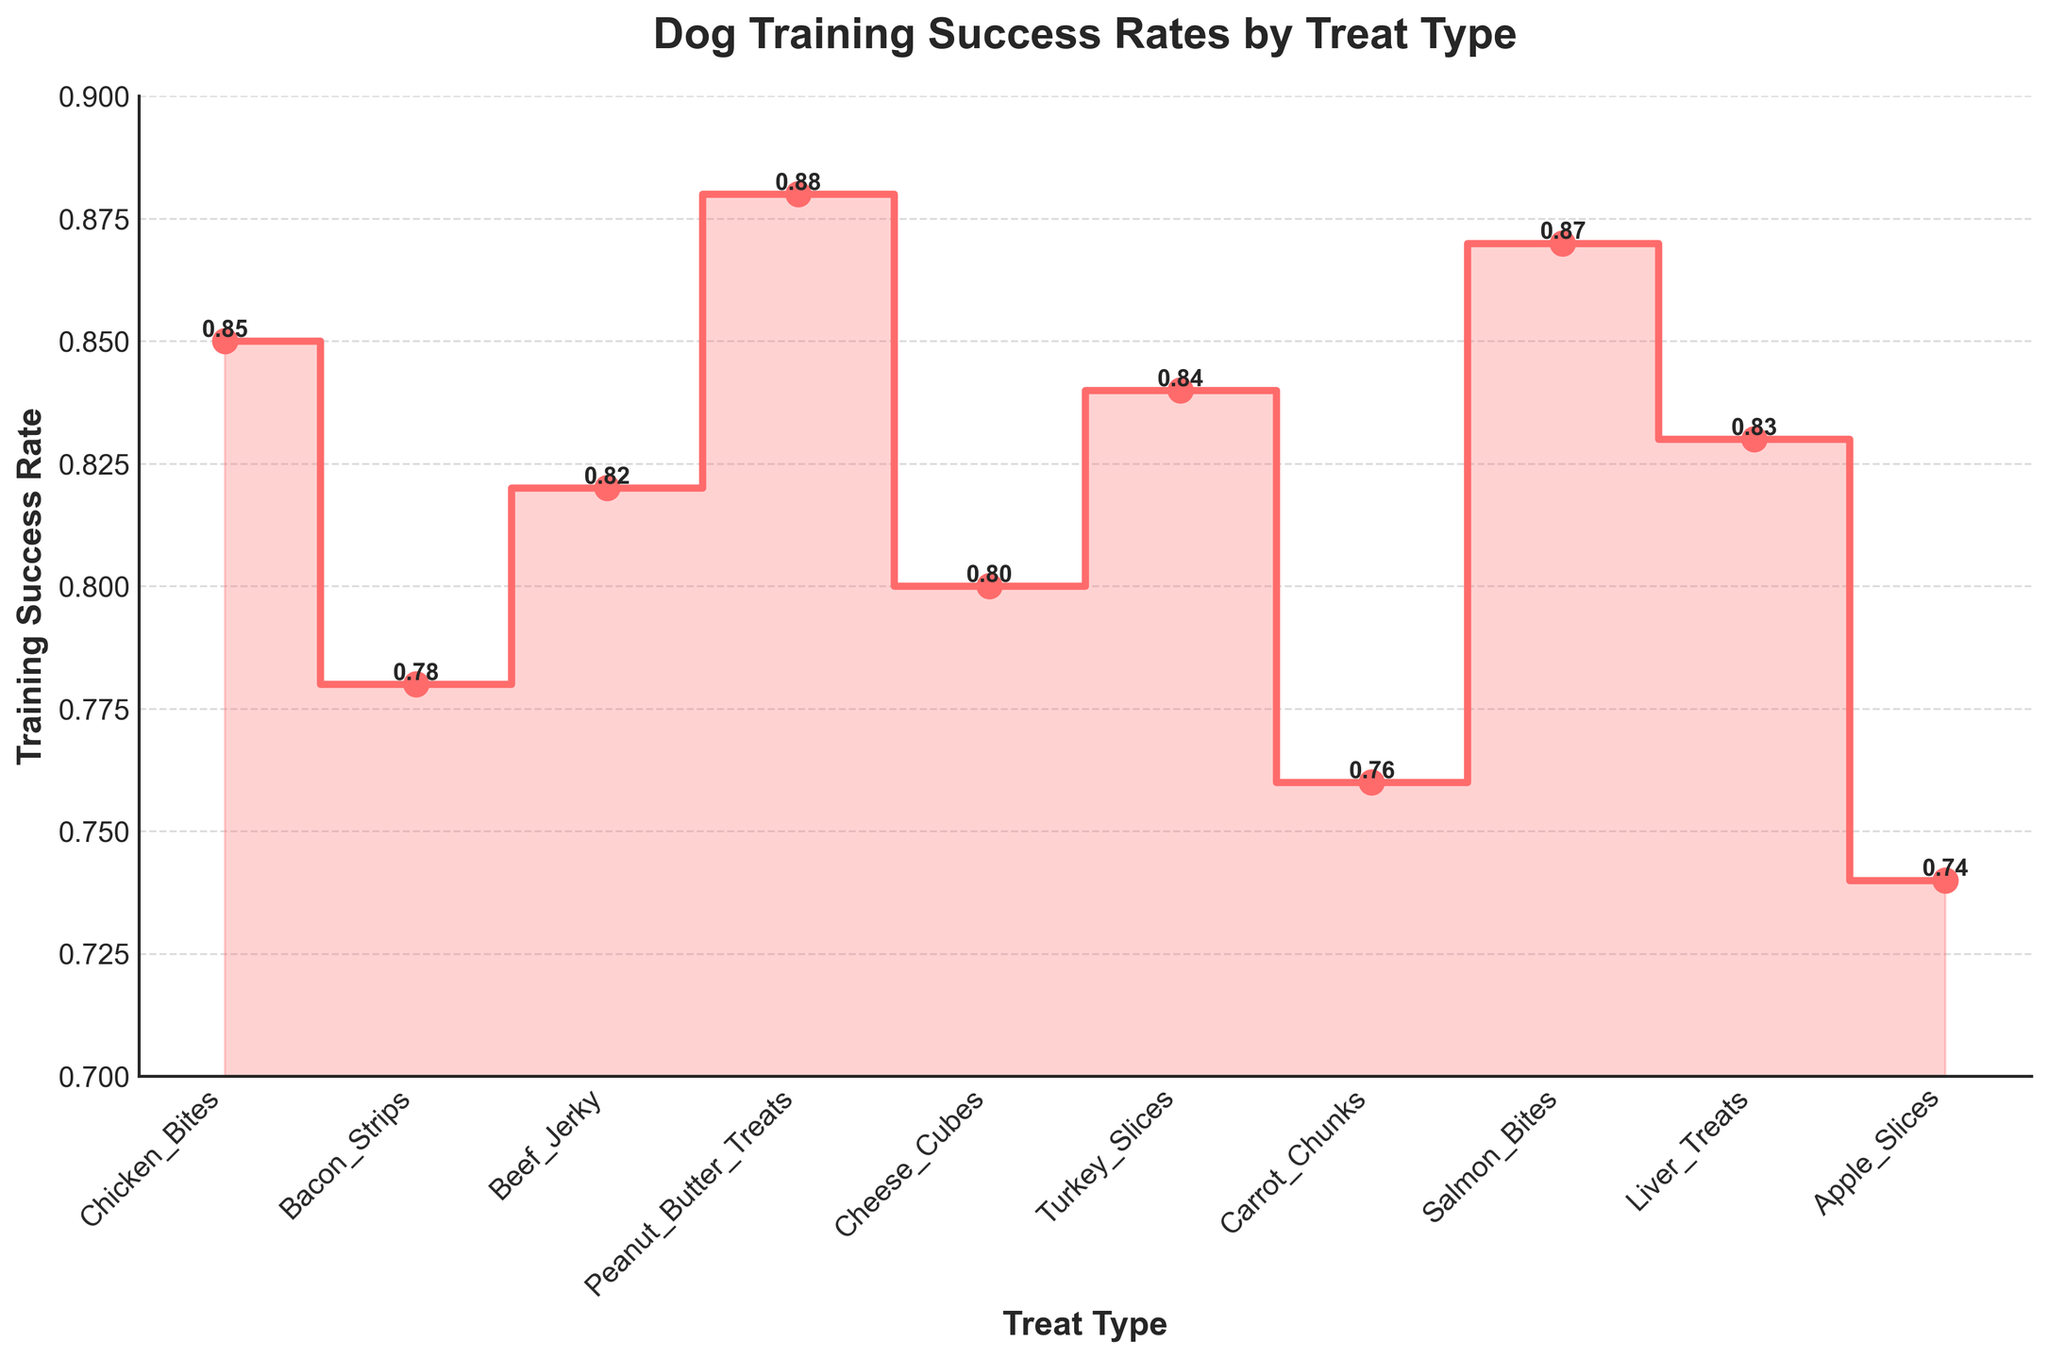What is the title of the figure? The title of the figure is the text at the top of the plot in larger and bold font, which gives a brief description of what the figure is about. In this case, it is "Dog Training Success Rates by Treat Type".
Answer: Dog Training Success Rates by Treat Type Which treat type has the highest training success rate? To determine the highest training success rate, look at the peak of the step plot. The highest value on the y-axis corresponds to the treat type "Peanut Butter Treats" with a success rate of 0.88.
Answer: Peanut Butter Treats What is the training success rate for Cheese Cubes? Locate "Cheese Cubes" on the x-axis of the plot, then follow the step to see where it intersects with the y-axis to get the value. "Cheese Cubes" has a success rate of 0.80.
Answer: 0.80 Which treat type has the lowest training success rate? To find the lowest training success rate, identify the lowest point on the y-axis. The treat type "Apple Slices" has the lowest success rate with a value of 0.74.
Answer: Apple Slices What is the range of training success rates in the figure? The range is calculated as the difference between the highest and lowest values on the y-axis. The highest success rate is 0.88 and the lowest is 0.74. Thus, the range is 0.88 - 0.74 = 0.14.
Answer: 0.14 How many treat types have a training success rate of 0.80 or higher? Count the number of treat types with success rates of 0.80 or higher. These are: "Chicken Bites" (0.85), "Bacon Strips" (0.78), "Beef Jerky" (0.82), "Peanut Butter Treats" (0.88), "Cheese Cubes" (0.80), "Turkey Slices" (0.84), "Salmon Bites" (0.87), and "Liver Treats" (0.83). There are 7 treat types.
Answer: 7 Which treat types have a training success rate between 0.80 and 0.84 inclusive? Check the treat types whose success rates fall between 0.80 and 0.84, inclusive. These are: "Beef Jerky" (0.82), "Turkey Slices" (0.84), "Cheese Cubes" (0.80), and "Liver Treats" (0.83).
Answer: Beef Jerky, Turkey Slices, Cheese Cubes, Liver Treats What is the difference in training success rates between "Salmon Bites" and "Carrot Chunks"? Calculate the difference between the success rates of these two treat types. "Salmon Bites" has a success rate of 0.87 and "Carrot Chunks" has a success rate of 0.76. The difference is 0.87 - 0.76 = 0.11.
Answer: 0.11 How does the training success rate for "Bacon Strips" compare to "Chicken Bites"? Compare the y-values of "Bacon Strips" and "Chicken Bites". "Bacon Strips" has a success rate of 0.78 and "Chicken Bites" has a success rate of 0.85. Therefore, "Chicken Bites" has a higher training success rate than "Bacon Strips".
Answer: Chicken Bites has a higher rate Which treat types show a success rate greater than 0.85? Identify the treats whose success rates are above 0.85. These are "Peanut Butter Treats" (0.88) and "Salmon Bites" (0.87).
Answer: Peanut Butter Treats, Salmon Bites 